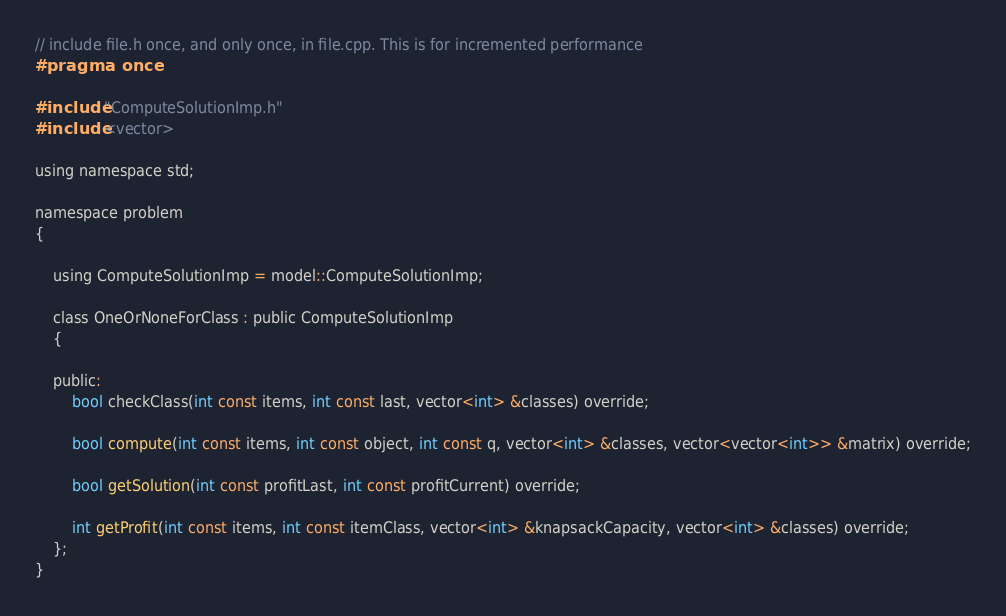<code> <loc_0><loc_0><loc_500><loc_500><_C_>// include file.h once, and only once, in file.cpp. This is for incremented performance
#pragma once

#include "ComputeSolutionImp.h"
#include <vector>

using namespace std;

namespace problem
{

	using ComputeSolutionImp = model::ComputeSolutionImp;

	class OneOrNoneForClass : public ComputeSolutionImp
	{

	public:
		bool checkClass(int const items, int const last, vector<int> &classes) override;

		bool compute(int const items, int const object, int const q, vector<int> &classes, vector<vector<int>> &matrix) override;

		bool getSolution(int const profitLast, int const profitCurrent) override;

		int getProfit(int const items, int const itemClass, vector<int> &knapsackCapacity, vector<int> &classes) override;
	};
}
</code> 